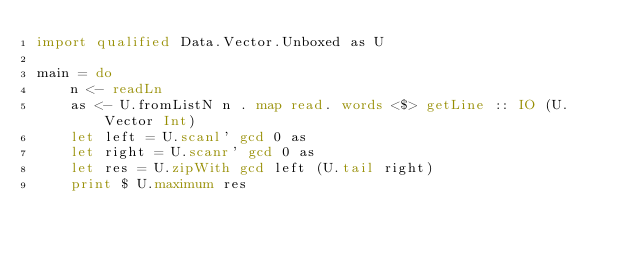Convert code to text. <code><loc_0><loc_0><loc_500><loc_500><_Haskell_>import qualified Data.Vector.Unboxed as U

main = do
    n <- readLn
    as <- U.fromListN n . map read. words <$> getLine :: IO (U.Vector Int)
    let left = U.scanl' gcd 0 as
    let right = U.scanr' gcd 0 as
    let res = U.zipWith gcd left (U.tail right)
    print $ U.maximum res</code> 